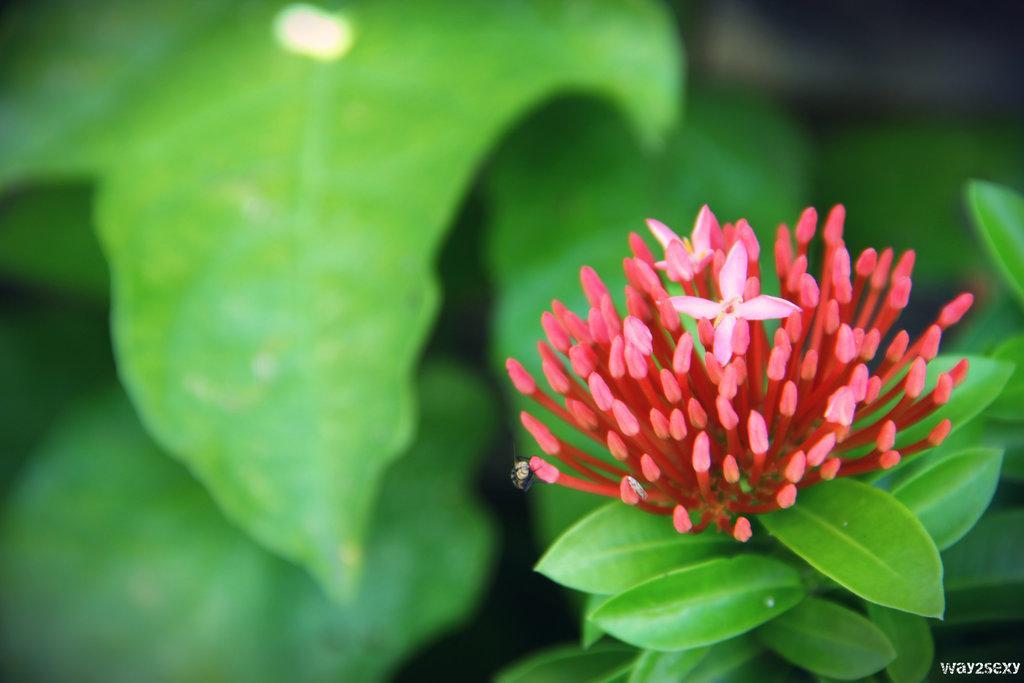In one or two sentences, can you explain what this image depicts? In the picture i can see a flower which is grown to the plant, i can see an insect and leaves which are in green color. 